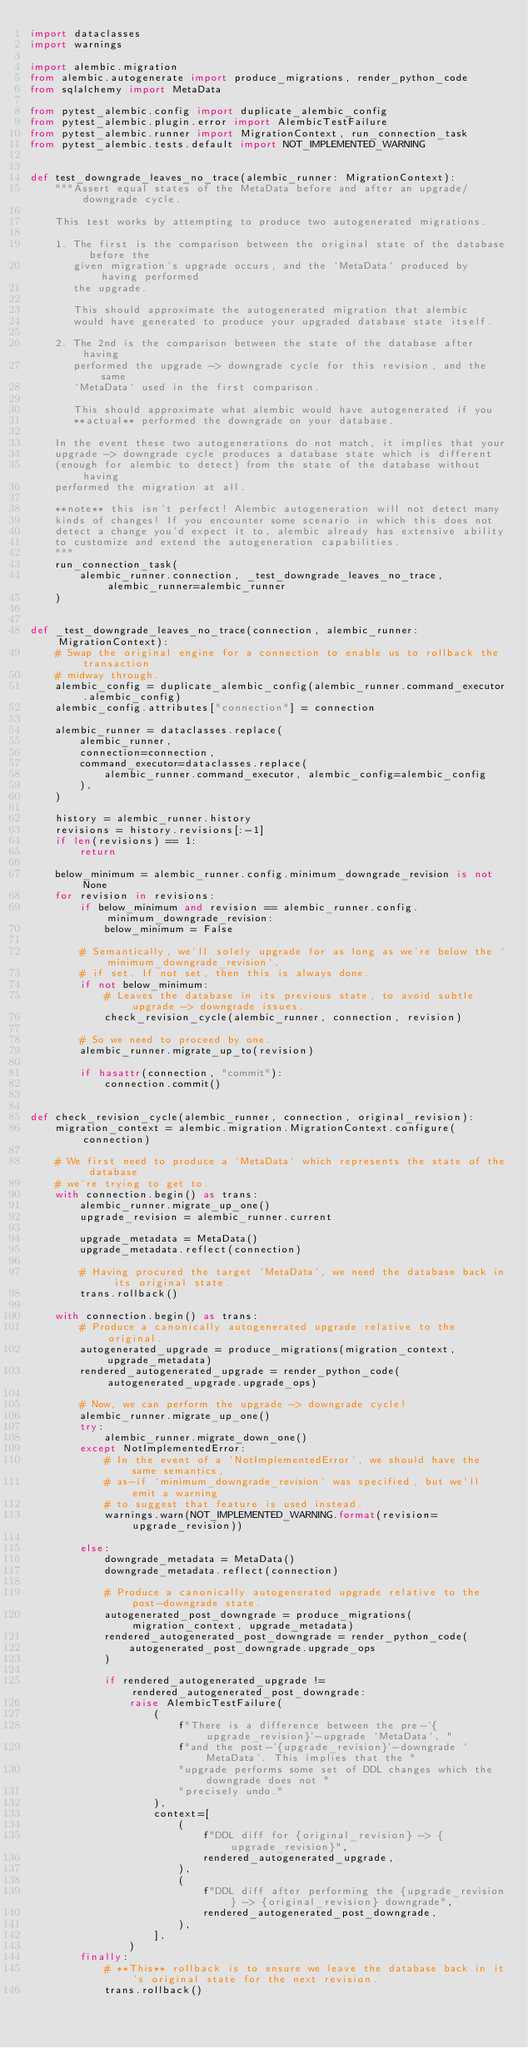Convert code to text. <code><loc_0><loc_0><loc_500><loc_500><_Python_>import dataclasses
import warnings

import alembic.migration
from alembic.autogenerate import produce_migrations, render_python_code
from sqlalchemy import MetaData

from pytest_alembic.config import duplicate_alembic_config
from pytest_alembic.plugin.error import AlembicTestFailure
from pytest_alembic.runner import MigrationContext, run_connection_task
from pytest_alembic.tests.default import NOT_IMPLEMENTED_WARNING


def test_downgrade_leaves_no_trace(alembic_runner: MigrationContext):
    """Assert equal states of the MetaData before and after an upgrade/downgrade cycle.

    This test works by attempting to produce two autogenerated migrations.

    1. The first is the comparison between the original state of the database before the
       given migration's upgrade occurs, and the `MetaData` produced by having performed
       the upgrade.

       This should approximate the autogenerated migration that alembic
       would have generated to produce your upgraded database state itself.

    2. The 2nd is the comparison between the state of the database after having
       performed the upgrade -> downgrade cycle for this revision, and the same
       `MetaData` used in the first comparison.

       This should approximate what alembic would have autogenerated if you
       **actual** performed the downgrade on your database.

    In the event these two autogenerations do not match, it implies that your
    upgrade -> downgrade cycle produces a database state which is different
    (enough for alembic to detect) from the state of the database without having
    performed the migration at all.

    **note** this isn't perfect! Alembic autogeneration will not detect many
    kinds of changes! If you encounter some scenario in which this does not
    detect a change you'd expect it to, alembic already has extensive ability
    to customize and extend the autogeneration capabilities.
    """
    run_connection_task(
        alembic_runner.connection, _test_downgrade_leaves_no_trace, alembic_runner=alembic_runner
    )


def _test_downgrade_leaves_no_trace(connection, alembic_runner: MigrationContext):
    # Swap the original engine for a connection to enable us to rollback the transaction
    # midway through.
    alembic_config = duplicate_alembic_config(alembic_runner.command_executor.alembic_config)
    alembic_config.attributes["connection"] = connection

    alembic_runner = dataclasses.replace(
        alembic_runner,
        connection=connection,
        command_executor=dataclasses.replace(
            alembic_runner.command_executor, alembic_config=alembic_config
        ),
    )

    history = alembic_runner.history
    revisions = history.revisions[:-1]
    if len(revisions) == 1:
        return

    below_minimum = alembic_runner.config.minimum_downgrade_revision is not None
    for revision in revisions:
        if below_minimum and revision == alembic_runner.config.minimum_downgrade_revision:
            below_minimum = False

        # Semantically, we'll solely upgrade for as long as we're below the `minimum_downgrade_revision`,
        # if set. If not set, then this is always done.
        if not below_minimum:
            # Leaves the database in its previous state, to avoid subtle upgrade -> downgrade issues.
            check_revision_cycle(alembic_runner, connection, revision)

        # So we need to proceed by one.
        alembic_runner.migrate_up_to(revision)

        if hasattr(connection, "commit"):
            connection.commit()


def check_revision_cycle(alembic_runner, connection, original_revision):
    migration_context = alembic.migration.MigrationContext.configure(connection)

    # We first need to produce a `MetaData` which represents the state of the database
    # we're trying to get to.
    with connection.begin() as trans:
        alembic_runner.migrate_up_one()
        upgrade_revision = alembic_runner.current

        upgrade_metadata = MetaData()
        upgrade_metadata.reflect(connection)

        # Having procured the target `MetaData`, we need the database back in its original state.
        trans.rollback()

    with connection.begin() as trans:
        # Produce a canonically autogenerated upgrade relative to the original.
        autogenerated_upgrade = produce_migrations(migration_context, upgrade_metadata)
        rendered_autogenerated_upgrade = render_python_code(autogenerated_upgrade.upgrade_ops)

        # Now, we can perform the upgrade -> downgrade cycle!
        alembic_runner.migrate_up_one()
        try:
            alembic_runner.migrate_down_one()
        except NotImplementedError:
            # In the event of a `NotImplementedError`, we should have the same semantics,
            # as-if `minimum_downgrade_revision` was specified, but we'll emit a warning
            # to suggest that feature is used instead.
            warnings.warn(NOT_IMPLEMENTED_WARNING.format(revision=upgrade_revision))

        else:
            downgrade_metadata = MetaData()
            downgrade_metadata.reflect(connection)

            # Produce a canonically autogenerated upgrade relative to the post-downgrade state.
            autogenerated_post_downgrade = produce_migrations(migration_context, upgrade_metadata)
            rendered_autogenerated_post_downgrade = render_python_code(
                autogenerated_post_downgrade.upgrade_ops
            )

            if rendered_autogenerated_upgrade != rendered_autogenerated_post_downgrade:
                raise AlembicTestFailure(
                    (
                        f"There is a difference between the pre-'{upgrade_revision}'-upgrade `MetaData`, "
                        f"and the post-'{upgrade_revision}'-downgrade `MetaData`. This implies that the "
                        "upgrade performs some set of DDL changes which the downgrade does not "
                        "precisely undo."
                    ),
                    context=[
                        (
                            f"DDL diff for {original_revision} -> {upgrade_revision}",
                            rendered_autogenerated_upgrade,
                        ),
                        (
                            f"DDL diff after performing the {upgrade_revision} -> {original_revision} downgrade",
                            rendered_autogenerated_post_downgrade,
                        ),
                    ],
                )
        finally:
            # **This** rollback is to ensure we leave the database back in it's original state for the next revision.
            trans.rollback()
</code> 